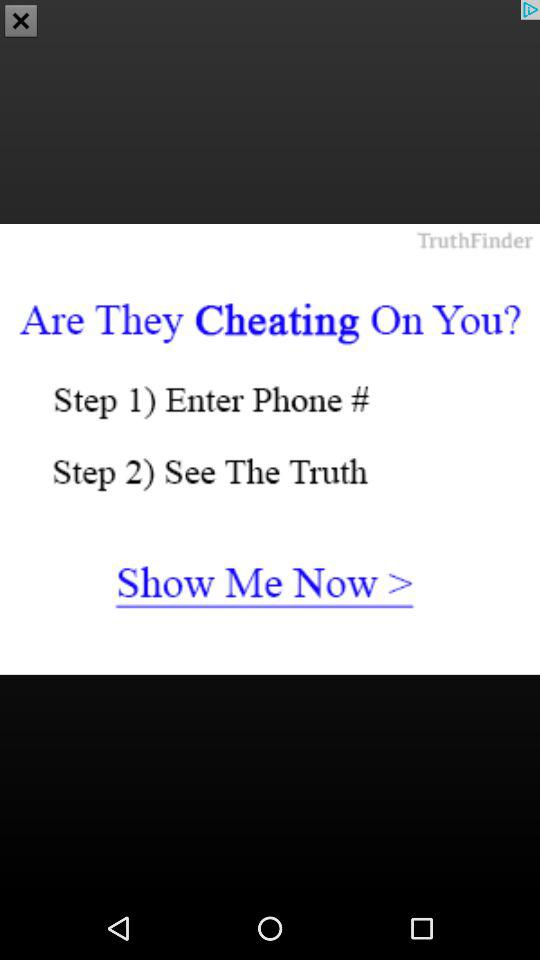How many steps are there in the process?
Answer the question using a single word or phrase. 2 